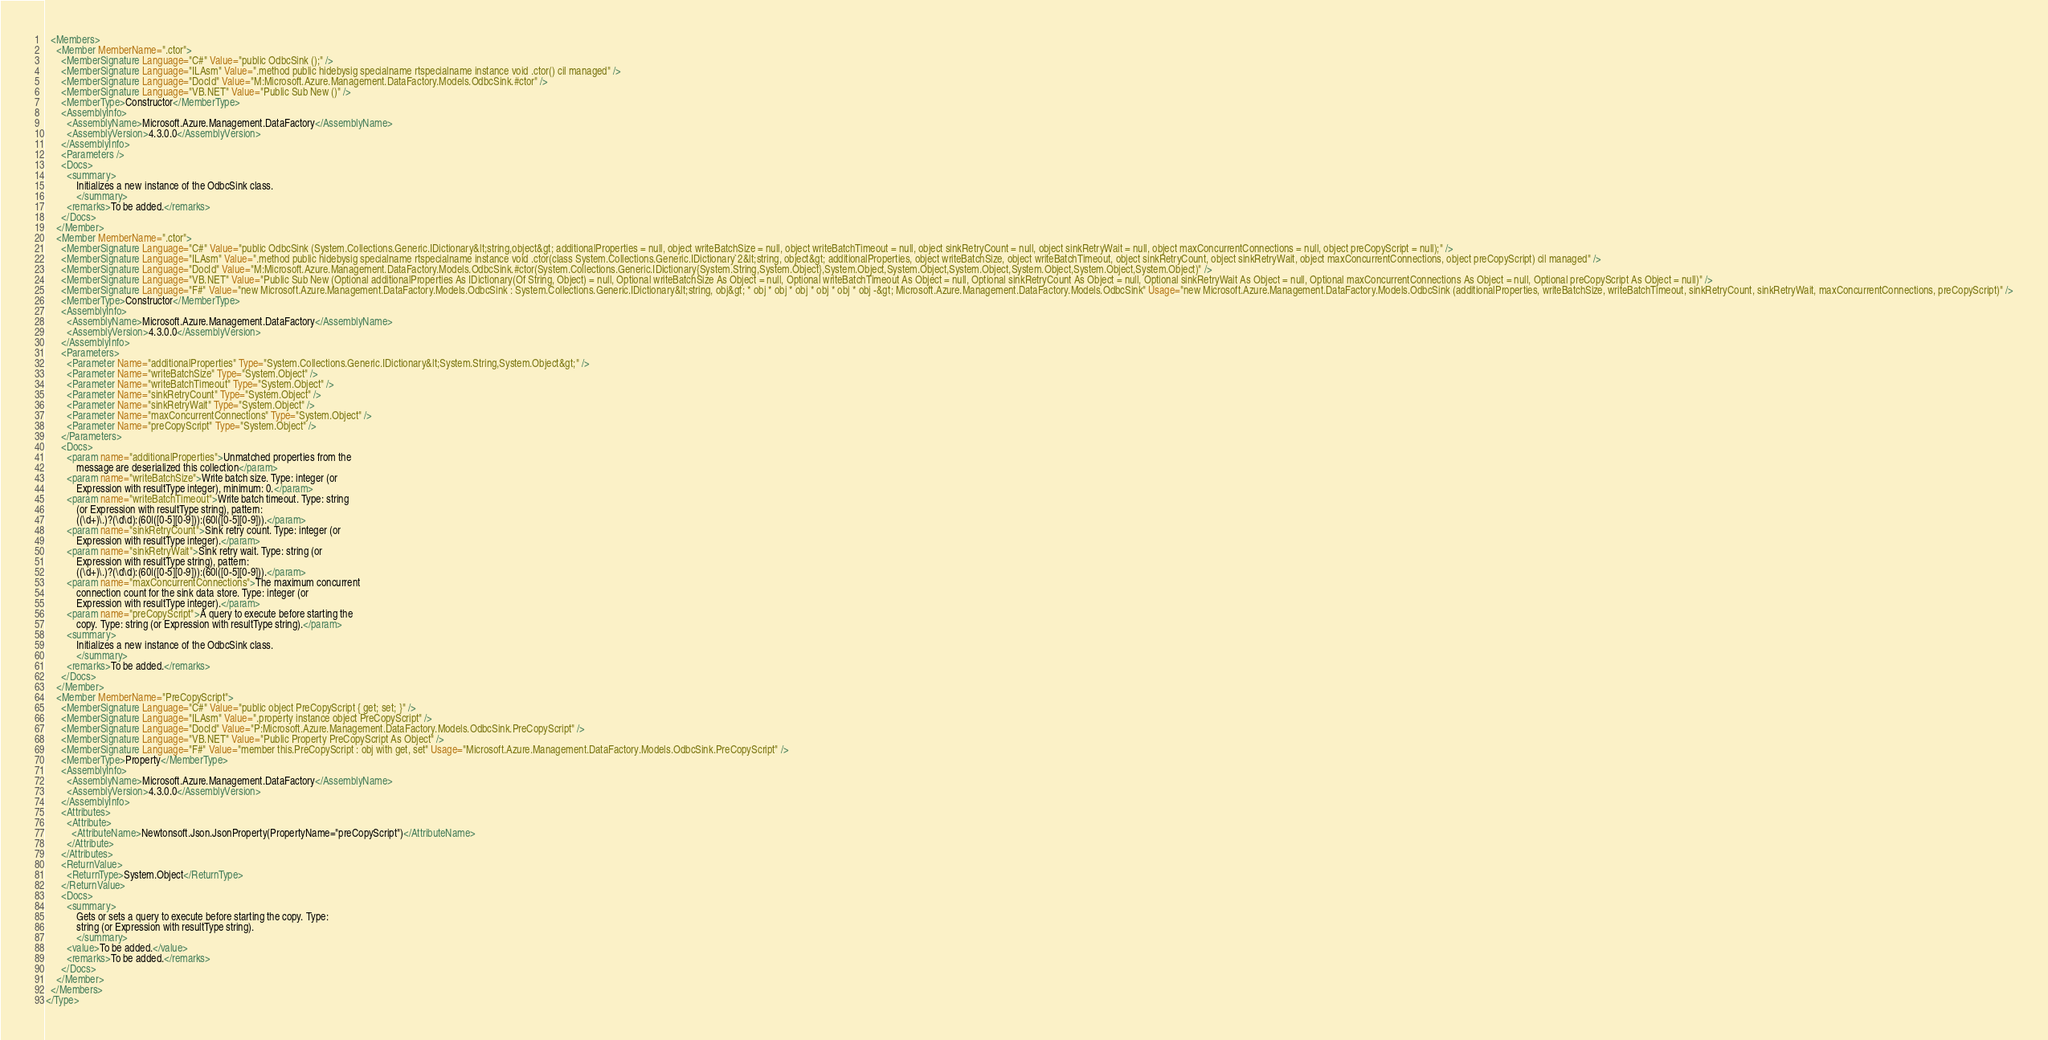Convert code to text. <code><loc_0><loc_0><loc_500><loc_500><_XML_>  <Members>
    <Member MemberName=".ctor">
      <MemberSignature Language="C#" Value="public OdbcSink ();" />
      <MemberSignature Language="ILAsm" Value=".method public hidebysig specialname rtspecialname instance void .ctor() cil managed" />
      <MemberSignature Language="DocId" Value="M:Microsoft.Azure.Management.DataFactory.Models.OdbcSink.#ctor" />
      <MemberSignature Language="VB.NET" Value="Public Sub New ()" />
      <MemberType>Constructor</MemberType>
      <AssemblyInfo>
        <AssemblyName>Microsoft.Azure.Management.DataFactory</AssemblyName>
        <AssemblyVersion>4.3.0.0</AssemblyVersion>
      </AssemblyInfo>
      <Parameters />
      <Docs>
        <summary>
            Initializes a new instance of the OdbcSink class.
            </summary>
        <remarks>To be added.</remarks>
      </Docs>
    </Member>
    <Member MemberName=".ctor">
      <MemberSignature Language="C#" Value="public OdbcSink (System.Collections.Generic.IDictionary&lt;string,object&gt; additionalProperties = null, object writeBatchSize = null, object writeBatchTimeout = null, object sinkRetryCount = null, object sinkRetryWait = null, object maxConcurrentConnections = null, object preCopyScript = null);" />
      <MemberSignature Language="ILAsm" Value=".method public hidebysig specialname rtspecialname instance void .ctor(class System.Collections.Generic.IDictionary`2&lt;string, object&gt; additionalProperties, object writeBatchSize, object writeBatchTimeout, object sinkRetryCount, object sinkRetryWait, object maxConcurrentConnections, object preCopyScript) cil managed" />
      <MemberSignature Language="DocId" Value="M:Microsoft.Azure.Management.DataFactory.Models.OdbcSink.#ctor(System.Collections.Generic.IDictionary{System.String,System.Object},System.Object,System.Object,System.Object,System.Object,System.Object,System.Object)" />
      <MemberSignature Language="VB.NET" Value="Public Sub New (Optional additionalProperties As IDictionary(Of String, Object) = null, Optional writeBatchSize As Object = null, Optional writeBatchTimeout As Object = null, Optional sinkRetryCount As Object = null, Optional sinkRetryWait As Object = null, Optional maxConcurrentConnections As Object = null, Optional preCopyScript As Object = null)" />
      <MemberSignature Language="F#" Value="new Microsoft.Azure.Management.DataFactory.Models.OdbcSink : System.Collections.Generic.IDictionary&lt;string, obj&gt; * obj * obj * obj * obj * obj * obj -&gt; Microsoft.Azure.Management.DataFactory.Models.OdbcSink" Usage="new Microsoft.Azure.Management.DataFactory.Models.OdbcSink (additionalProperties, writeBatchSize, writeBatchTimeout, sinkRetryCount, sinkRetryWait, maxConcurrentConnections, preCopyScript)" />
      <MemberType>Constructor</MemberType>
      <AssemblyInfo>
        <AssemblyName>Microsoft.Azure.Management.DataFactory</AssemblyName>
        <AssemblyVersion>4.3.0.0</AssemblyVersion>
      </AssemblyInfo>
      <Parameters>
        <Parameter Name="additionalProperties" Type="System.Collections.Generic.IDictionary&lt;System.String,System.Object&gt;" />
        <Parameter Name="writeBatchSize" Type="System.Object" />
        <Parameter Name="writeBatchTimeout" Type="System.Object" />
        <Parameter Name="sinkRetryCount" Type="System.Object" />
        <Parameter Name="sinkRetryWait" Type="System.Object" />
        <Parameter Name="maxConcurrentConnections" Type="System.Object" />
        <Parameter Name="preCopyScript" Type="System.Object" />
      </Parameters>
      <Docs>
        <param name="additionalProperties">Unmatched properties from the
            message are deserialized this collection</param>
        <param name="writeBatchSize">Write batch size. Type: integer (or
            Expression with resultType integer), minimum: 0.</param>
        <param name="writeBatchTimeout">Write batch timeout. Type: string
            (or Expression with resultType string), pattern:
            ((\d+)\.)?(\d\d):(60|([0-5][0-9])):(60|([0-5][0-9])).</param>
        <param name="sinkRetryCount">Sink retry count. Type: integer (or
            Expression with resultType integer).</param>
        <param name="sinkRetryWait">Sink retry wait. Type: string (or
            Expression with resultType string), pattern:
            ((\d+)\.)?(\d\d):(60|([0-5][0-9])):(60|([0-5][0-9])).</param>
        <param name="maxConcurrentConnections">The maximum concurrent
            connection count for the sink data store. Type: integer (or
            Expression with resultType integer).</param>
        <param name="preCopyScript">A query to execute before starting the
            copy. Type: string (or Expression with resultType string).</param>
        <summary>
            Initializes a new instance of the OdbcSink class.
            </summary>
        <remarks>To be added.</remarks>
      </Docs>
    </Member>
    <Member MemberName="PreCopyScript">
      <MemberSignature Language="C#" Value="public object PreCopyScript { get; set; }" />
      <MemberSignature Language="ILAsm" Value=".property instance object PreCopyScript" />
      <MemberSignature Language="DocId" Value="P:Microsoft.Azure.Management.DataFactory.Models.OdbcSink.PreCopyScript" />
      <MemberSignature Language="VB.NET" Value="Public Property PreCopyScript As Object" />
      <MemberSignature Language="F#" Value="member this.PreCopyScript : obj with get, set" Usage="Microsoft.Azure.Management.DataFactory.Models.OdbcSink.PreCopyScript" />
      <MemberType>Property</MemberType>
      <AssemblyInfo>
        <AssemblyName>Microsoft.Azure.Management.DataFactory</AssemblyName>
        <AssemblyVersion>4.3.0.0</AssemblyVersion>
      </AssemblyInfo>
      <Attributes>
        <Attribute>
          <AttributeName>Newtonsoft.Json.JsonProperty(PropertyName="preCopyScript")</AttributeName>
        </Attribute>
      </Attributes>
      <ReturnValue>
        <ReturnType>System.Object</ReturnType>
      </ReturnValue>
      <Docs>
        <summary>
            Gets or sets a query to execute before starting the copy. Type:
            string (or Expression with resultType string).
            </summary>
        <value>To be added.</value>
        <remarks>To be added.</remarks>
      </Docs>
    </Member>
  </Members>
</Type>
</code> 